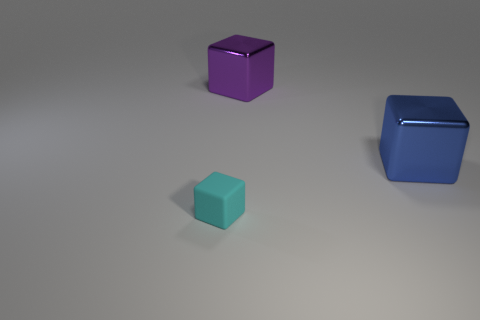Are there any other things that have the same material as the small object?
Keep it short and to the point. No. How many things are either cubes that are in front of the big blue thing or small rubber objects?
Make the answer very short. 1. Are there any blue cubes of the same size as the blue object?
Give a very brief answer. No. Is the number of big gray shiny cylinders less than the number of blue cubes?
Provide a succinct answer. Yes. How many blocks are either matte things or blue metal things?
Offer a terse response. 2. There is a cube that is on the left side of the large blue metallic cube and in front of the purple metal block; what is its size?
Provide a short and direct response. Small. Is the number of small cyan matte cubes left of the large blue block less than the number of tiny rubber things?
Offer a very short reply. No. Are the cyan cube and the big blue cube made of the same material?
Give a very brief answer. No. What number of objects are either large green metal spheres or small cyan rubber cubes?
Make the answer very short. 1. How many blue things are the same material as the small cube?
Offer a terse response. 0. 